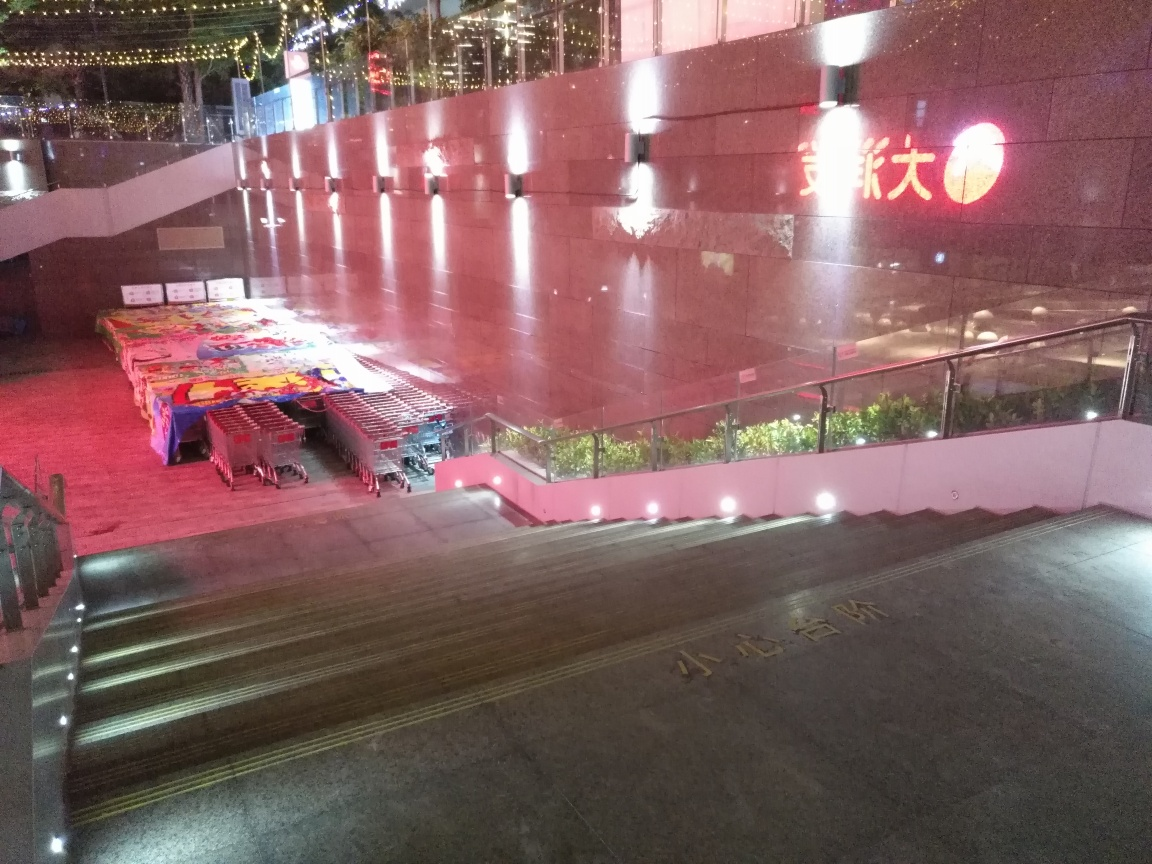What is the overall clarity of the image?
A. High
B. Clear
C. Very low
D. Moderate The clarity of the image is not very low; it seems more accurate to rate it as moderate due to the presence of noise and reduced sharpness, possibly because of low lighting or movement during the capture. The key details of the scene are still discernible, including the text on the building, the arrangement of the carts, and the light fixtures. 